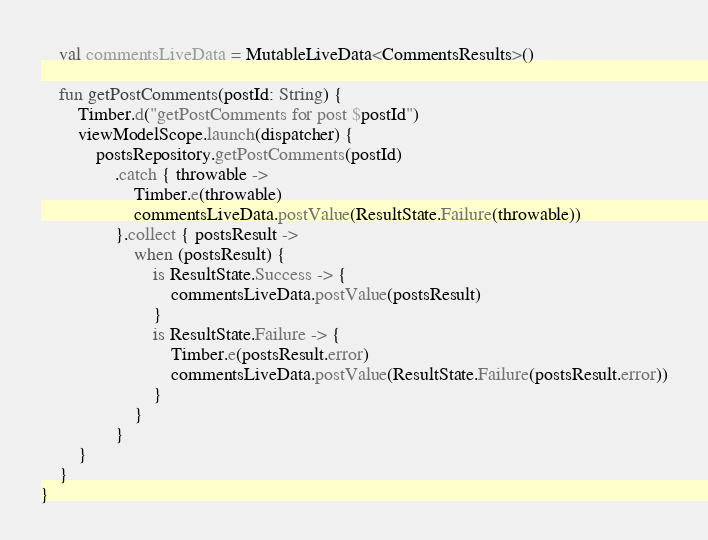Convert code to text. <code><loc_0><loc_0><loc_500><loc_500><_Kotlin_>
    val commentsLiveData = MutableLiveData<CommentsResults>()

    fun getPostComments(postId: String) {
        Timber.d("getPostComments for post $postId")
        viewModelScope.launch(dispatcher) {
            postsRepository.getPostComments(postId)
                .catch { throwable ->
                    Timber.e(throwable)
                    commentsLiveData.postValue(ResultState.Failure(throwable))
                }.collect { postsResult ->
                    when (postsResult) {
                        is ResultState.Success -> {
                            commentsLiveData.postValue(postsResult)
                        }
                        is ResultState.Failure -> {
                            Timber.e(postsResult.error)
                            commentsLiveData.postValue(ResultState.Failure(postsResult.error))
                        }
                    }
                }
        }
    }
}</code> 